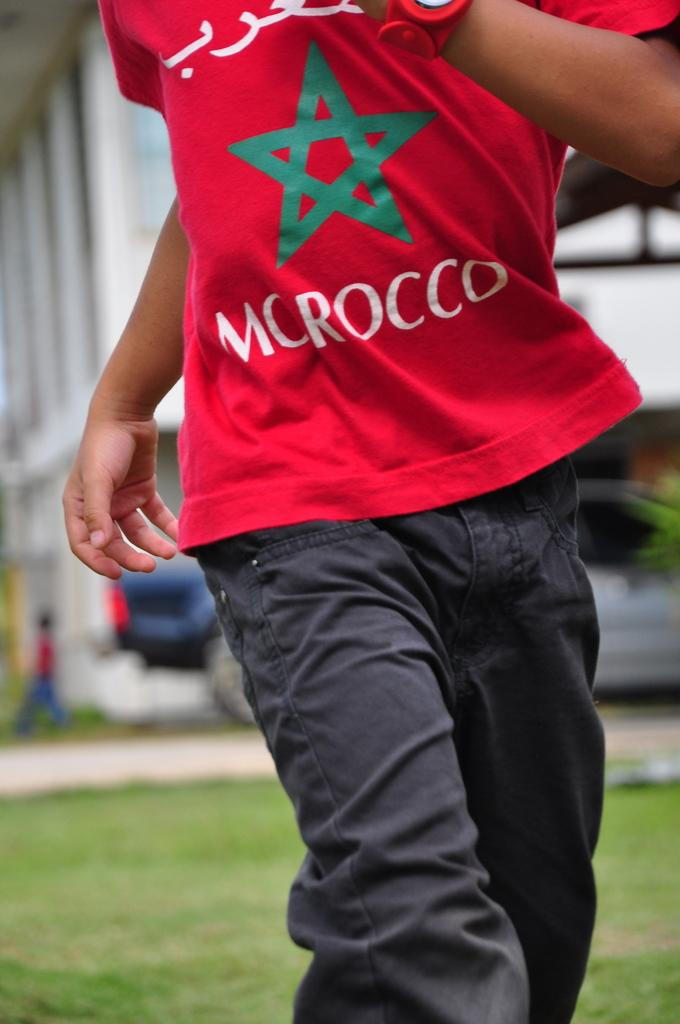<image>
Render a clear and concise summary of the photo. A guy in a red shirt with a green star and the word Morocco on the front. 